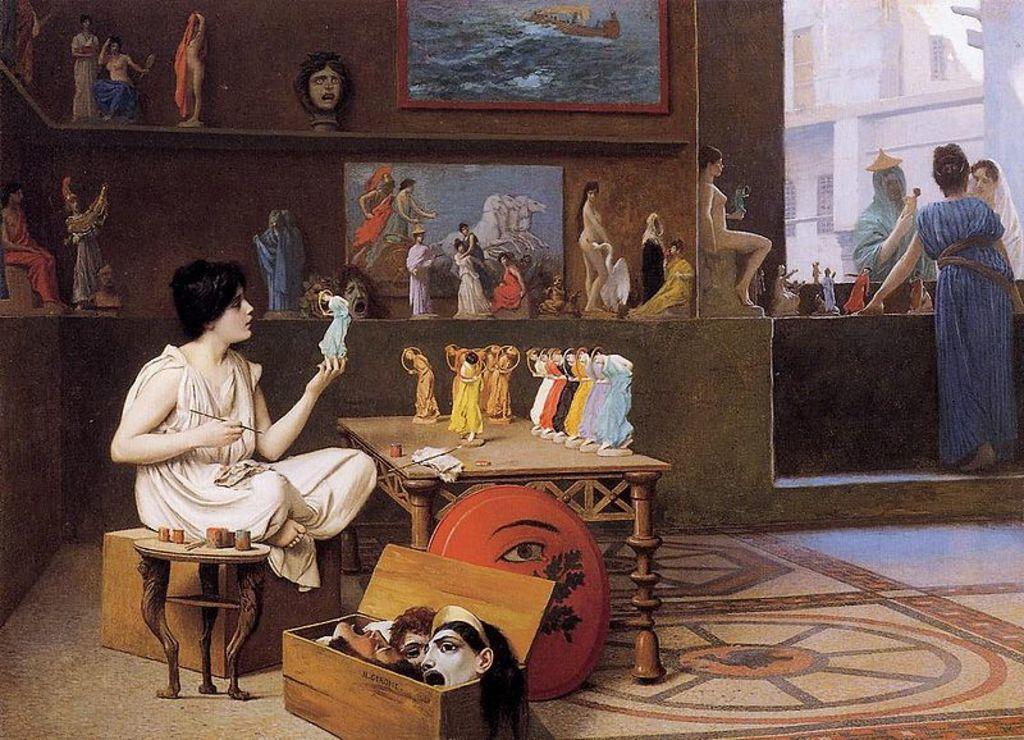Describe this image in one or two sentences. A woman is sitting and adding colors to idols. There are idols on the table in front of her. There are some more idols in the shelves behind the woman along with paintings. Another woman is selling these idols. There are two other women and building in the background. 